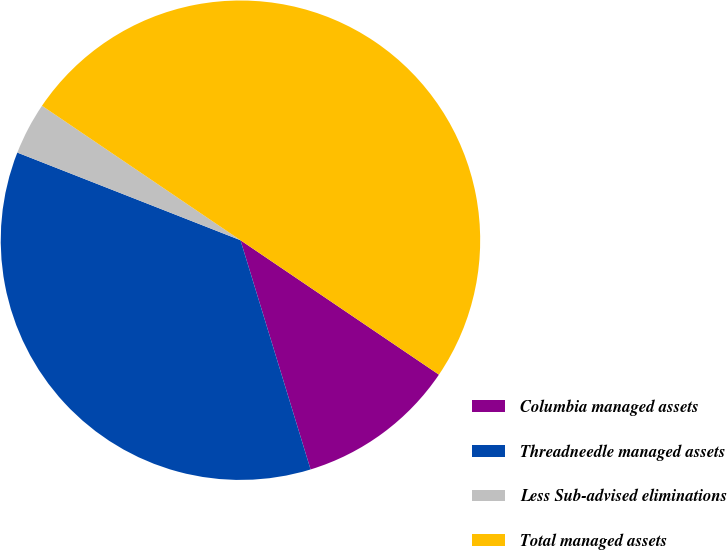<chart> <loc_0><loc_0><loc_500><loc_500><pie_chart><fcel>Columbia managed assets<fcel>Threadneedle managed assets<fcel>Less Sub-advised eliminations<fcel>Total managed assets<nl><fcel>10.8%<fcel>35.68%<fcel>3.52%<fcel>50.0%<nl></chart> 